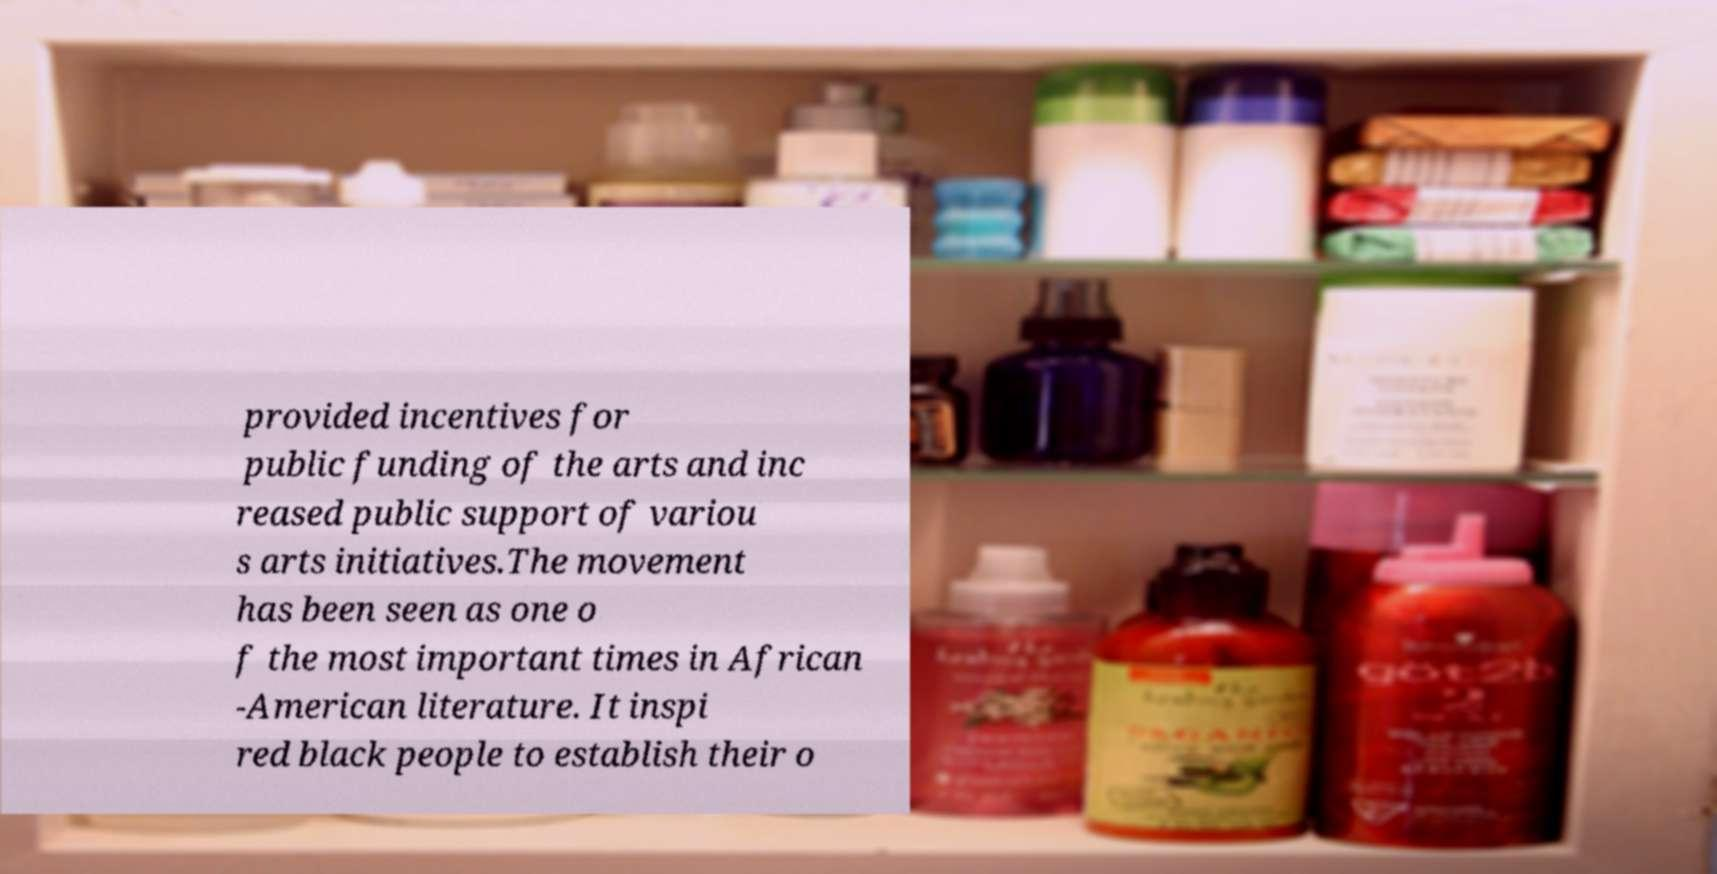Could you extract and type out the text from this image? provided incentives for public funding of the arts and inc reased public support of variou s arts initiatives.The movement has been seen as one o f the most important times in African -American literature. It inspi red black people to establish their o 